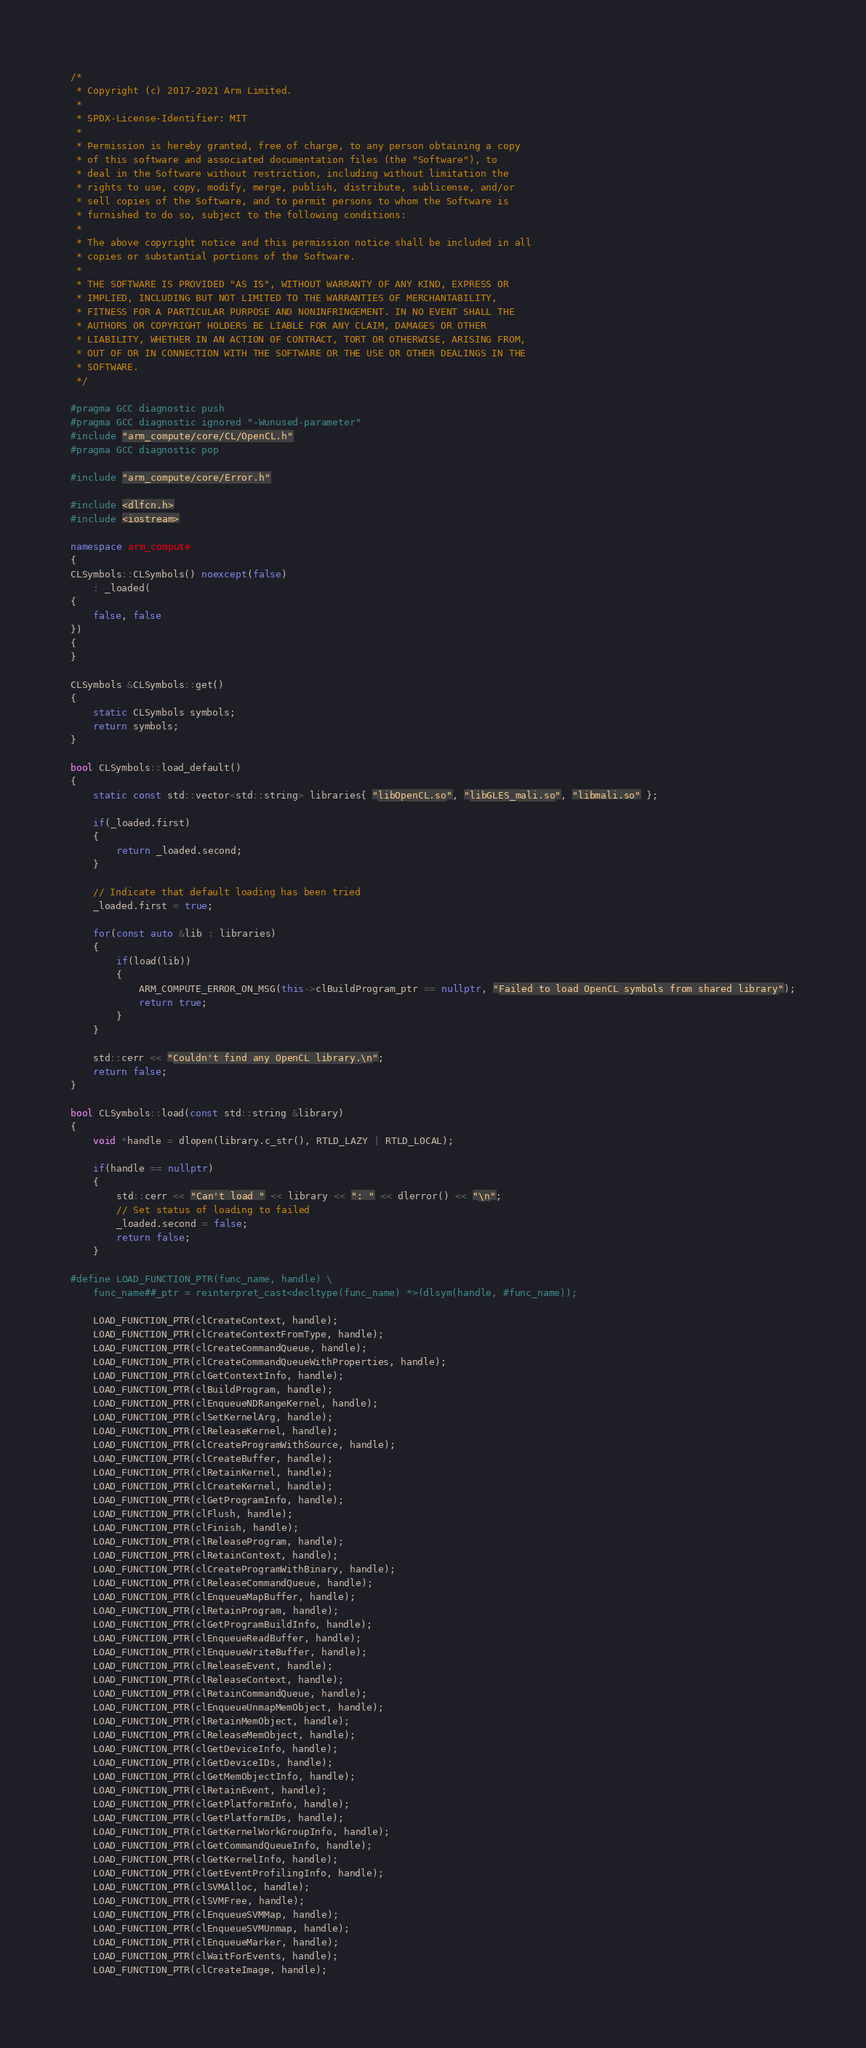<code> <loc_0><loc_0><loc_500><loc_500><_C++_>/*
 * Copyright (c) 2017-2021 Arm Limited.
 *
 * SPDX-License-Identifier: MIT
 *
 * Permission is hereby granted, free of charge, to any person obtaining a copy
 * of this software and associated documentation files (the "Software"), to
 * deal in the Software without restriction, including without limitation the
 * rights to use, copy, modify, merge, publish, distribute, sublicense, and/or
 * sell copies of the Software, and to permit persons to whom the Software is
 * furnished to do so, subject to the following conditions:
 *
 * The above copyright notice and this permission notice shall be included in all
 * copies or substantial portions of the Software.
 *
 * THE SOFTWARE IS PROVIDED "AS IS", WITHOUT WARRANTY OF ANY KIND, EXPRESS OR
 * IMPLIED, INCLUDING BUT NOT LIMITED TO THE WARRANTIES OF MERCHANTABILITY,
 * FITNESS FOR A PARTICULAR PURPOSE AND NONINFRINGEMENT. IN NO EVENT SHALL THE
 * AUTHORS OR COPYRIGHT HOLDERS BE LIABLE FOR ANY CLAIM, DAMAGES OR OTHER
 * LIABILITY, WHETHER IN AN ACTION OF CONTRACT, TORT OR OTHERWISE, ARISING FROM,
 * OUT OF OR IN CONNECTION WITH THE SOFTWARE OR THE USE OR OTHER DEALINGS IN THE
 * SOFTWARE.
 */

#pragma GCC diagnostic push
#pragma GCC diagnostic ignored "-Wunused-parameter"
#include "arm_compute/core/CL/OpenCL.h"
#pragma GCC diagnostic pop

#include "arm_compute/core/Error.h"

#include <dlfcn.h>
#include <iostream>

namespace arm_compute
{
CLSymbols::CLSymbols() noexcept(false)
    : _loaded(
{
    false, false
})
{
}

CLSymbols &CLSymbols::get()
{
    static CLSymbols symbols;
    return symbols;
}

bool CLSymbols::load_default()
{
    static const std::vector<std::string> libraries{ "libOpenCL.so", "libGLES_mali.so", "libmali.so" };

    if(_loaded.first)
    {
        return _loaded.second;
    }

    // Indicate that default loading has been tried
    _loaded.first = true;

    for(const auto &lib : libraries)
    {
        if(load(lib))
        {
            ARM_COMPUTE_ERROR_ON_MSG(this->clBuildProgram_ptr == nullptr, "Failed to load OpenCL symbols from shared library");
            return true;
        }
    }

    std::cerr << "Couldn't find any OpenCL library.\n";
    return false;
}

bool CLSymbols::load(const std::string &library)
{
    void *handle = dlopen(library.c_str(), RTLD_LAZY | RTLD_LOCAL);

    if(handle == nullptr)
    {
        std::cerr << "Can't load " << library << ": " << dlerror() << "\n";
        // Set status of loading to failed
        _loaded.second = false;
        return false;
    }

#define LOAD_FUNCTION_PTR(func_name, handle) \
    func_name##_ptr = reinterpret_cast<decltype(func_name) *>(dlsym(handle, #func_name));

    LOAD_FUNCTION_PTR(clCreateContext, handle);
    LOAD_FUNCTION_PTR(clCreateContextFromType, handle);
    LOAD_FUNCTION_PTR(clCreateCommandQueue, handle);
    LOAD_FUNCTION_PTR(clCreateCommandQueueWithProperties, handle);
    LOAD_FUNCTION_PTR(clGetContextInfo, handle);
    LOAD_FUNCTION_PTR(clBuildProgram, handle);
    LOAD_FUNCTION_PTR(clEnqueueNDRangeKernel, handle);
    LOAD_FUNCTION_PTR(clSetKernelArg, handle);
    LOAD_FUNCTION_PTR(clReleaseKernel, handle);
    LOAD_FUNCTION_PTR(clCreateProgramWithSource, handle);
    LOAD_FUNCTION_PTR(clCreateBuffer, handle);
    LOAD_FUNCTION_PTR(clRetainKernel, handle);
    LOAD_FUNCTION_PTR(clCreateKernel, handle);
    LOAD_FUNCTION_PTR(clGetProgramInfo, handle);
    LOAD_FUNCTION_PTR(clFlush, handle);
    LOAD_FUNCTION_PTR(clFinish, handle);
    LOAD_FUNCTION_PTR(clReleaseProgram, handle);
    LOAD_FUNCTION_PTR(clRetainContext, handle);
    LOAD_FUNCTION_PTR(clCreateProgramWithBinary, handle);
    LOAD_FUNCTION_PTR(clReleaseCommandQueue, handle);
    LOAD_FUNCTION_PTR(clEnqueueMapBuffer, handle);
    LOAD_FUNCTION_PTR(clRetainProgram, handle);
    LOAD_FUNCTION_PTR(clGetProgramBuildInfo, handle);
    LOAD_FUNCTION_PTR(clEnqueueReadBuffer, handle);
    LOAD_FUNCTION_PTR(clEnqueueWriteBuffer, handle);
    LOAD_FUNCTION_PTR(clReleaseEvent, handle);
    LOAD_FUNCTION_PTR(clReleaseContext, handle);
    LOAD_FUNCTION_PTR(clRetainCommandQueue, handle);
    LOAD_FUNCTION_PTR(clEnqueueUnmapMemObject, handle);
    LOAD_FUNCTION_PTR(clRetainMemObject, handle);
    LOAD_FUNCTION_PTR(clReleaseMemObject, handle);
    LOAD_FUNCTION_PTR(clGetDeviceInfo, handle);
    LOAD_FUNCTION_PTR(clGetDeviceIDs, handle);
    LOAD_FUNCTION_PTR(clGetMemObjectInfo, handle);
    LOAD_FUNCTION_PTR(clRetainEvent, handle);
    LOAD_FUNCTION_PTR(clGetPlatformInfo, handle);
    LOAD_FUNCTION_PTR(clGetPlatformIDs, handle);
    LOAD_FUNCTION_PTR(clGetKernelWorkGroupInfo, handle);
    LOAD_FUNCTION_PTR(clGetCommandQueueInfo, handle);
    LOAD_FUNCTION_PTR(clGetKernelInfo, handle);
    LOAD_FUNCTION_PTR(clGetEventProfilingInfo, handle);
    LOAD_FUNCTION_PTR(clSVMAlloc, handle);
    LOAD_FUNCTION_PTR(clSVMFree, handle);
    LOAD_FUNCTION_PTR(clEnqueueSVMMap, handle);
    LOAD_FUNCTION_PTR(clEnqueueSVMUnmap, handle);
    LOAD_FUNCTION_PTR(clEnqueueMarker, handle);
    LOAD_FUNCTION_PTR(clWaitForEvents, handle);
    LOAD_FUNCTION_PTR(clCreateImage, handle);</code> 